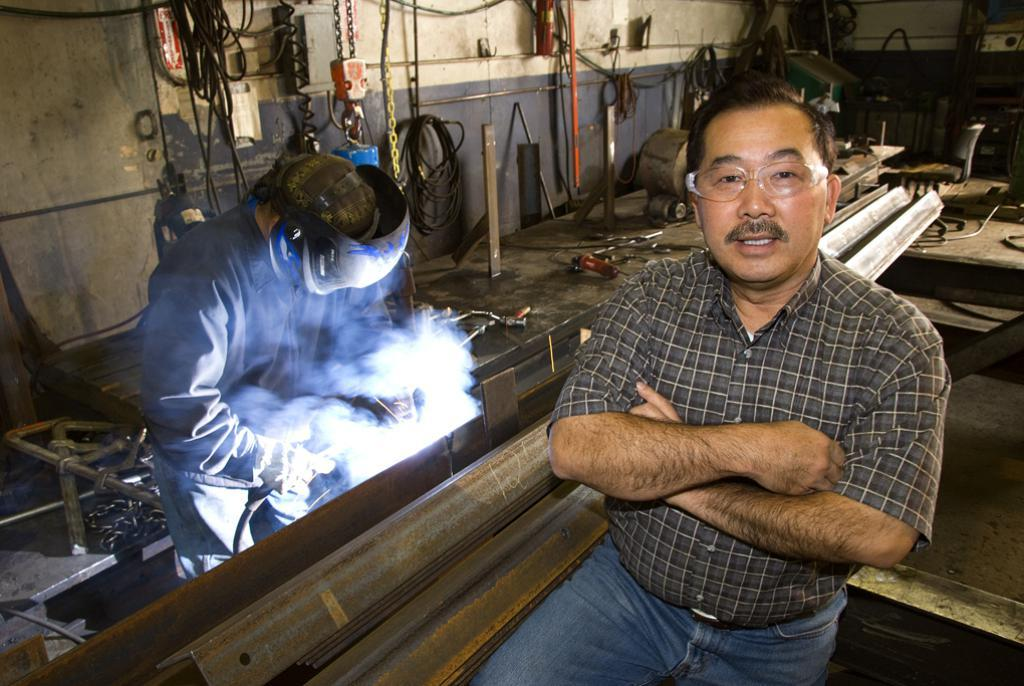How many people are in the image? There are two people in the image. Can you describe the man on the right side? The man on the right side is wearing spectacles. What objects are beside the man on the right side? There are metal rods beside the man on the right side. What is the opinion of the tomatoes in the image? There are no tomatoes present in the image, so it is not possible to determine their opinion. 